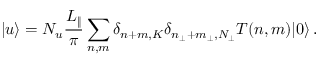Convert formula to latex. <formula><loc_0><loc_0><loc_500><loc_500>| u \rangle = N _ { u } \frac { L _ { \| } } { \pi } \sum _ { n , m } \delta _ { n + m , K } \delta _ { n _ { \perp } + m _ { \perp } , N _ { \perp } } T ( n , m ) | 0 \rangle \, .</formula> 